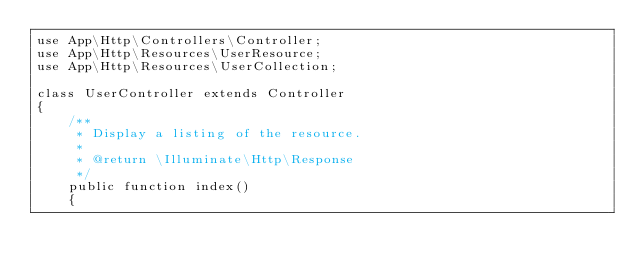<code> <loc_0><loc_0><loc_500><loc_500><_PHP_>use App\Http\Controllers\Controller;
use App\Http\Resources\UserResource;
use App\Http\Resources\UserCollection;

class UserController extends Controller
{
    /**
     * Display a listing of the resource.
     *
     * @return \Illuminate\Http\Response
     */
    public function index()
    {</code> 